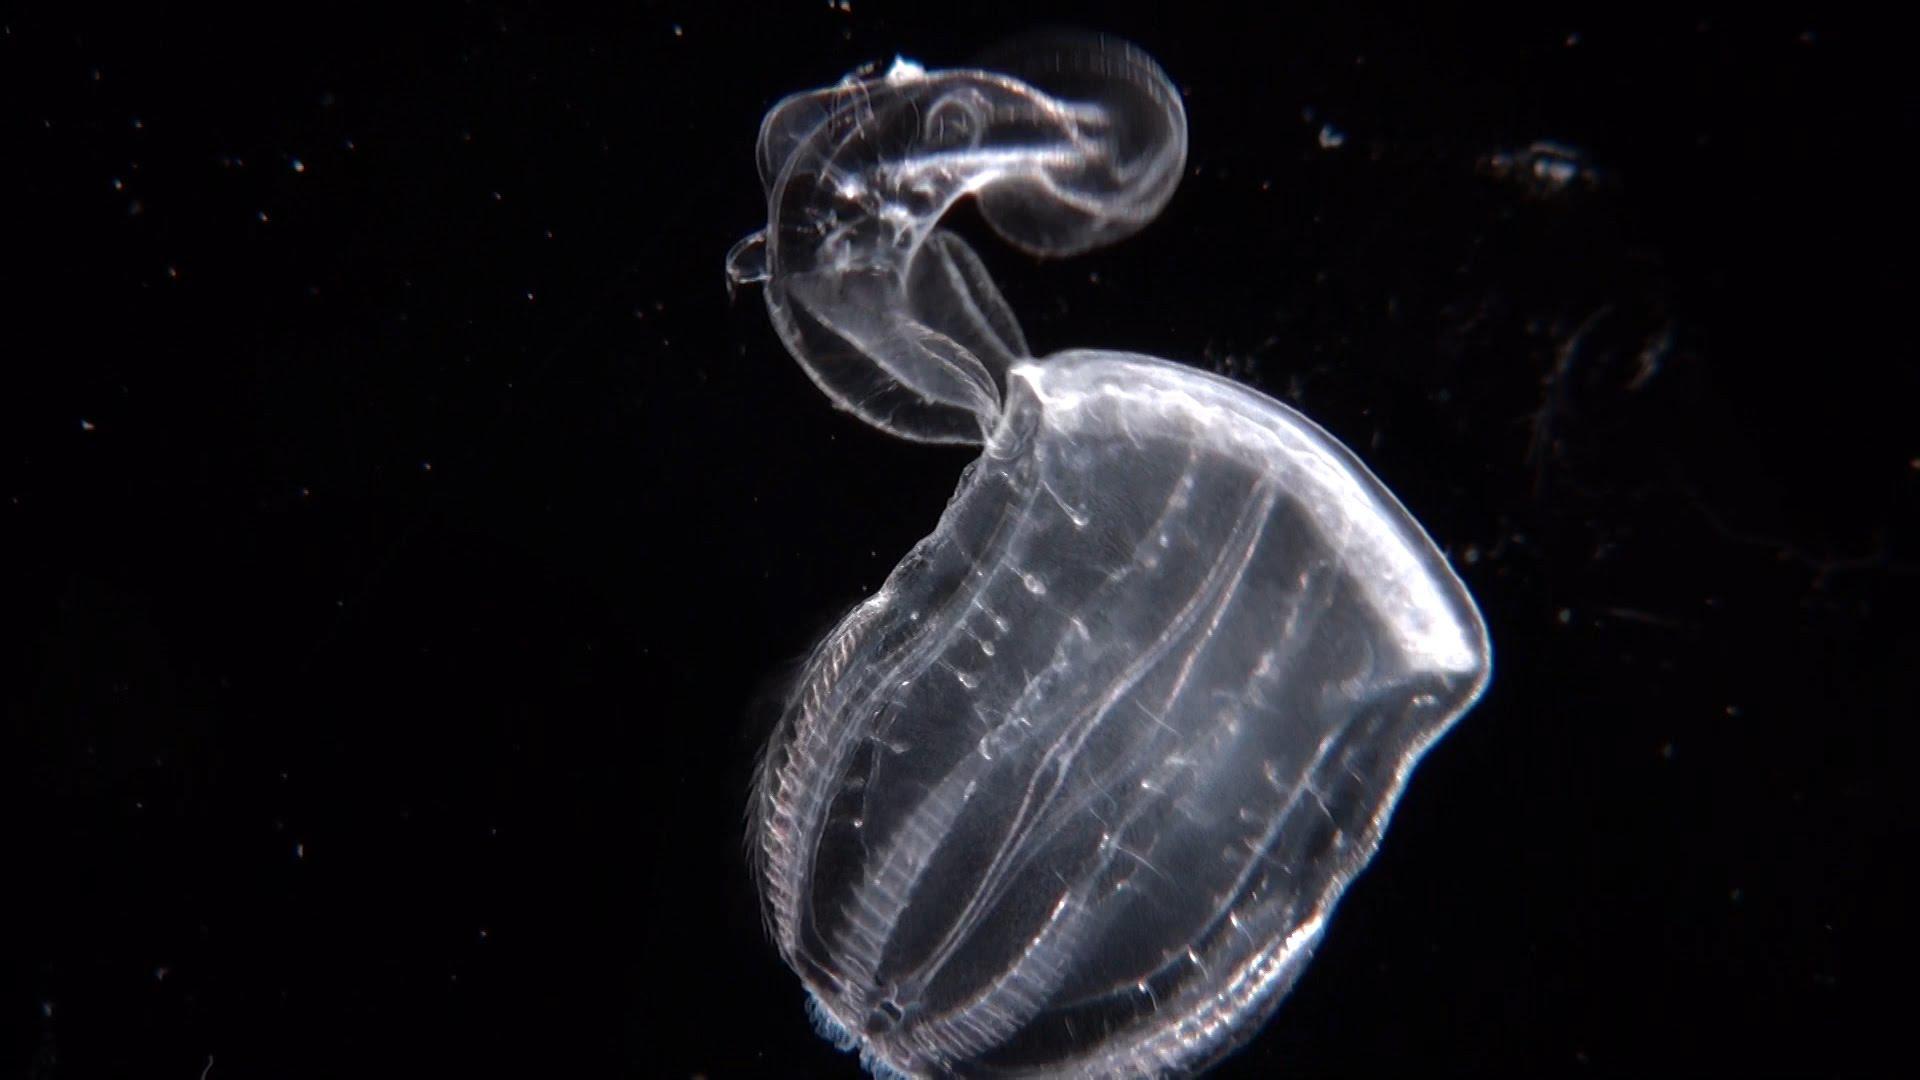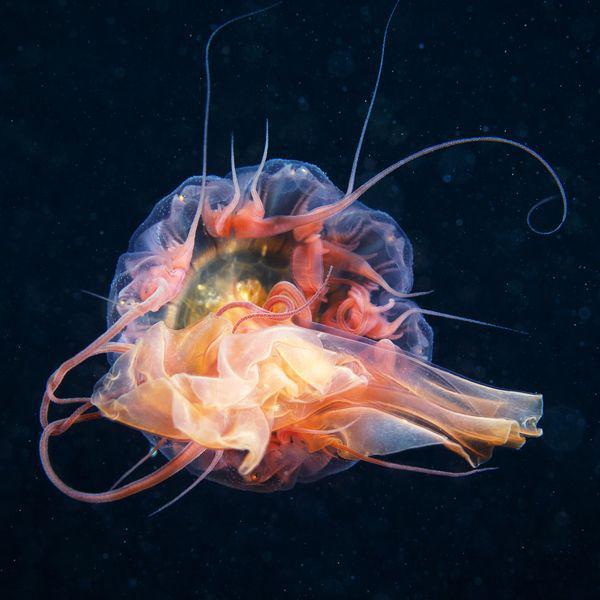The first image is the image on the left, the second image is the image on the right. For the images displayed, is the sentence "In at least one of the images, there is greenish light coming through the water above the jellyfish." factually correct? Answer yes or no. No. The first image is the image on the left, the second image is the image on the right. Considering the images on both sides, is "Each image includes a jellyfish with multiple threadlike tentacles, and each jellyfish image has a blue-green multi-tone background." valid? Answer yes or no. No. 